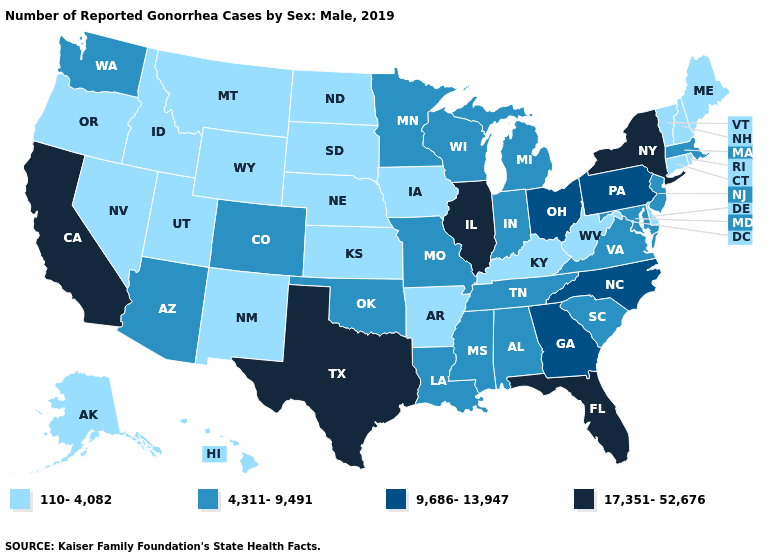Which states have the highest value in the USA?
Concise answer only. California, Florida, Illinois, New York, Texas. Name the states that have a value in the range 4,311-9,491?
Write a very short answer. Alabama, Arizona, Colorado, Indiana, Louisiana, Maryland, Massachusetts, Michigan, Minnesota, Mississippi, Missouri, New Jersey, Oklahoma, South Carolina, Tennessee, Virginia, Washington, Wisconsin. What is the highest value in the USA?
Quick response, please. 17,351-52,676. Among the states that border Nevada , which have the lowest value?
Answer briefly. Idaho, Oregon, Utah. What is the lowest value in the Northeast?
Concise answer only. 110-4,082. What is the value of Missouri?
Be succinct. 4,311-9,491. Does Wyoming have the lowest value in the USA?
Be succinct. Yes. Is the legend a continuous bar?
Answer briefly. No. Does Missouri have a lower value than Washington?
Answer briefly. No. Does Tennessee have the same value as Mississippi?
Answer briefly. Yes. Which states hav the highest value in the West?
Write a very short answer. California. Name the states that have a value in the range 17,351-52,676?
Concise answer only. California, Florida, Illinois, New York, Texas. Among the states that border Colorado , does Arizona have the highest value?
Answer briefly. Yes. What is the value of South Carolina?
Keep it brief. 4,311-9,491. Does Washington have the highest value in the USA?
Short answer required. No. 